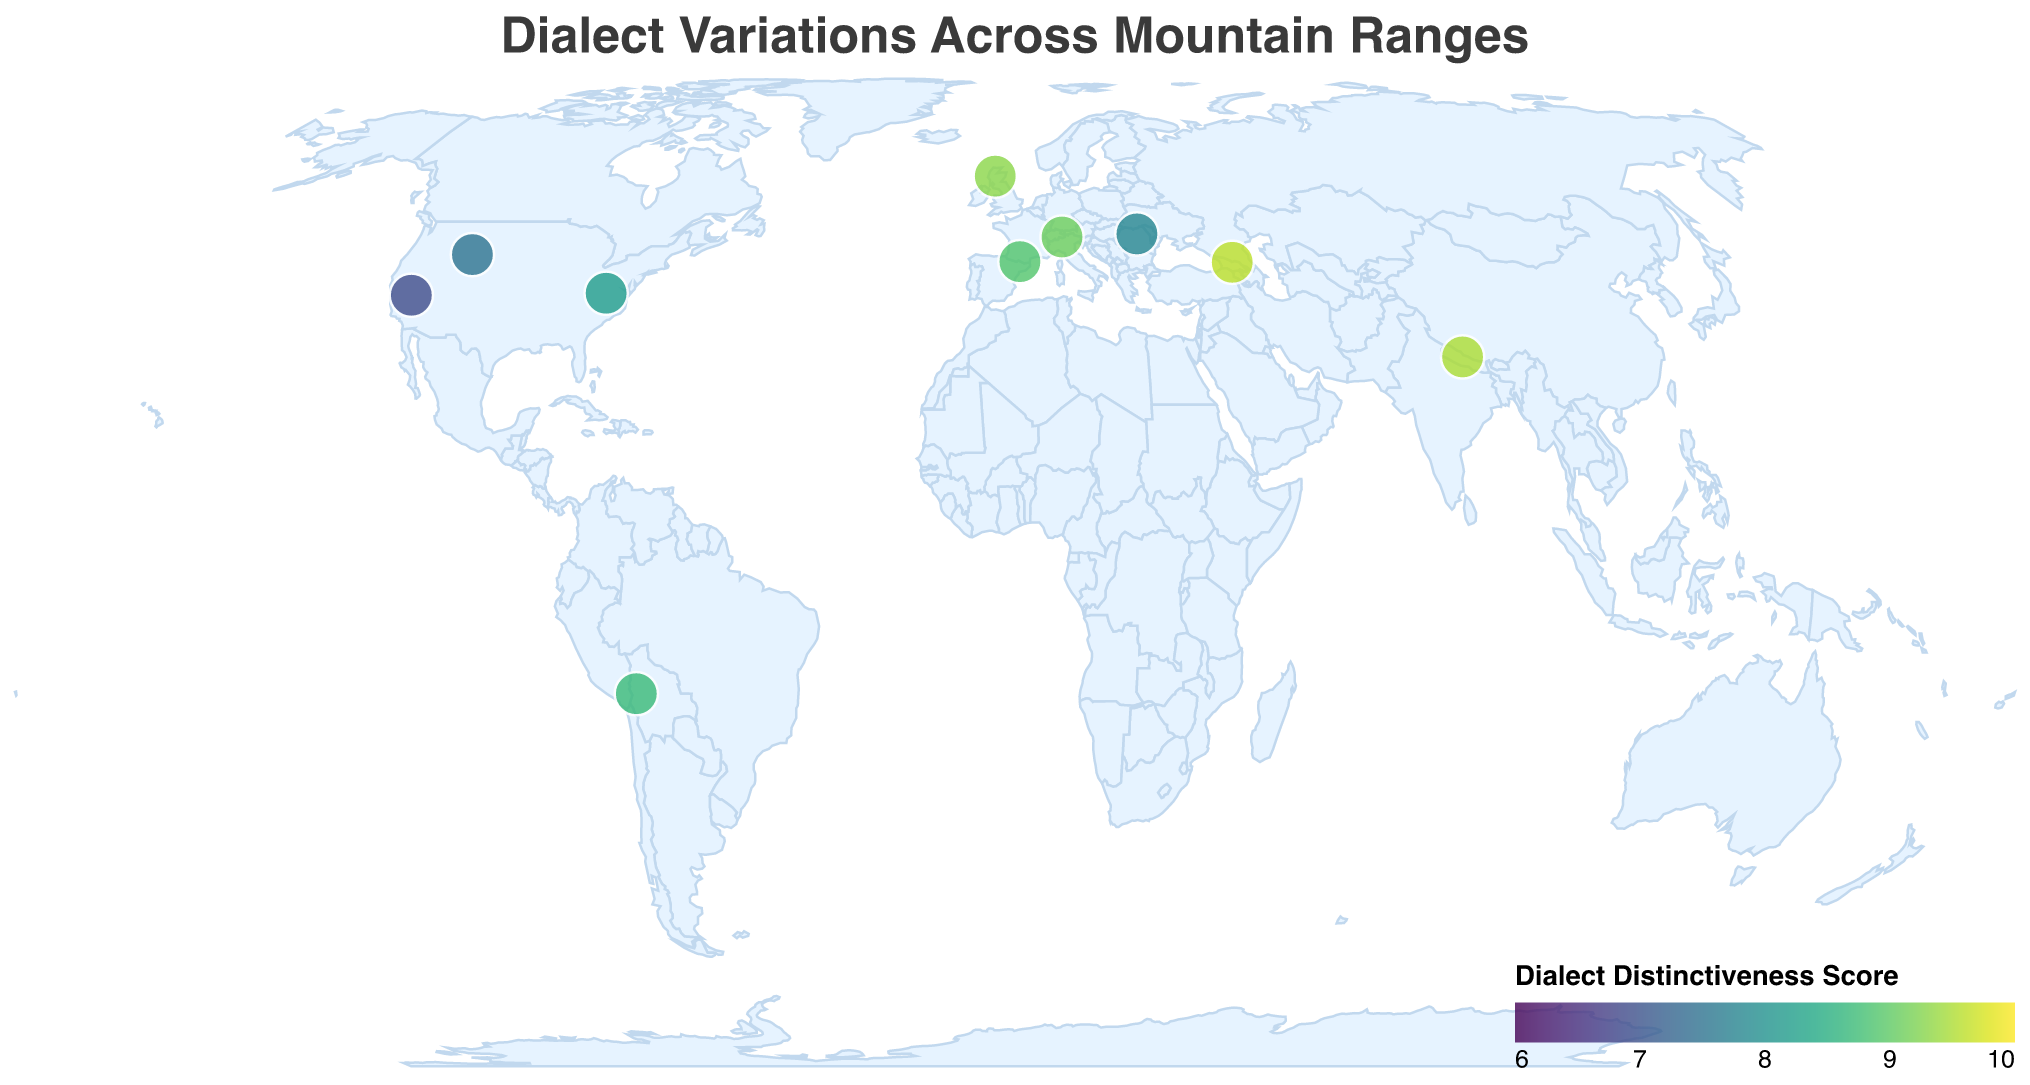What's the title of the plot? The title of the plot is displayed at the top, typically in a larger and bolder font compared to other text elements. The title for this plot is "Dialect Variations Across Mountain Ranges", as stated in the data provided.
Answer: Dialect Variations Across Mountain Ranges How many dialect variations are shown on the plot? Each circle on the plot represents a distinct dialect variation. By counting the entries listed in the data, we find there are ten dialect variations shown: Southern Appalachian, Mountain West, Swiss German, Andean Spanish, Nepali, Catalan, Transylvanian, Scottish Gaelic, California English, and Georgian.
Answer: 10 Which mountain range has the highest dialect distinctiveness score, and what is the score? By examining the color gradient on the plot, we find that the darkest circle, indicating the highest dialect distinctiveness score, corresponds to the Caucasus Mountains. The tooltip or legend verifies that the distinctiveness score is 9.6.
Answer: Caucasus Mountains, 9.6 Compare the dialect distinctiveness scores of the Rocky Mountains and the Sierra Nevada. Which one is higher and by how much? According to the data, the Rocky Mountains have a score of 7.5, while the Sierra Nevada has a score of 6.9. The difference can be found by subtracting the Sierra Nevada's score from the Rocky Mountains', giving us: 7.5 - 6.9.
Answer: Rocky Mountains by 0.6 What is the average dialect distinctiveness score of all the mountain ranges shown? To find the average score, sum all the scores and then divide by the number of data points (10). The sum of the scores is: 8.2 + 7.5 + 9.1 + 8.7 + 9.5 + 8.9 + 7.8 + 9.3 + 6.9 + 9.6 = 85.5. The average is 85.5 / 10.
Answer: 8.55 How many mountain ranges have a dialect distinctiveness score greater than 9? We count the entries with a dialect distinctiveness score greater than 9 from the data: Swiss German (9.1), Nepali (9.5), Scottish Gaelic (9.3), and Georgian (9.6). There are four such entries.
Answer: 4 Which mountain range corresponds to the latitude 46.5 and longitude 9.8, and what is the dialect variation there? The specified coordinates correspond to the Alps, based on the data provided. The dialect variation there is Swiss German.
Answer: Alps, Swiss German Is the dialect variation 'Catalan' located closer to the Pyrenees or the Carpathian Mountains in the plot? To determine proximity, compare the latitude and longitude of the Pyrenees (42.6, 1.0) and the Carpathian Mountains (47.0, 25.5). 'Catalan' corresponds to the Pyrenees, and considering both latitudinal and longitudinal differences, it is much closer to the Pyrenees.
Answer: Pyrenees What range of dialect distinctiveness scores is used for the color gradient in the plot? The legend indicates that the color gradient is scaled between distinctiveness scores of 6 to 10, with lighter colors representing lower scores and darker colors representing higher scores.
Answer: 6 to 10 What is the latitude and longitude of the mountain range with the dialect variation 'Scottish Gaelic', and what is its distinctiveness score? According to the data, 'Scottish Gaelic' is spoken in the Scottish Highlands with a latitude of 57.0 and a longitude of -4.5. The distinctiveness score is 9.3.
Answer: Latitude 57.0, Longitude -4.5, Score 9.3 